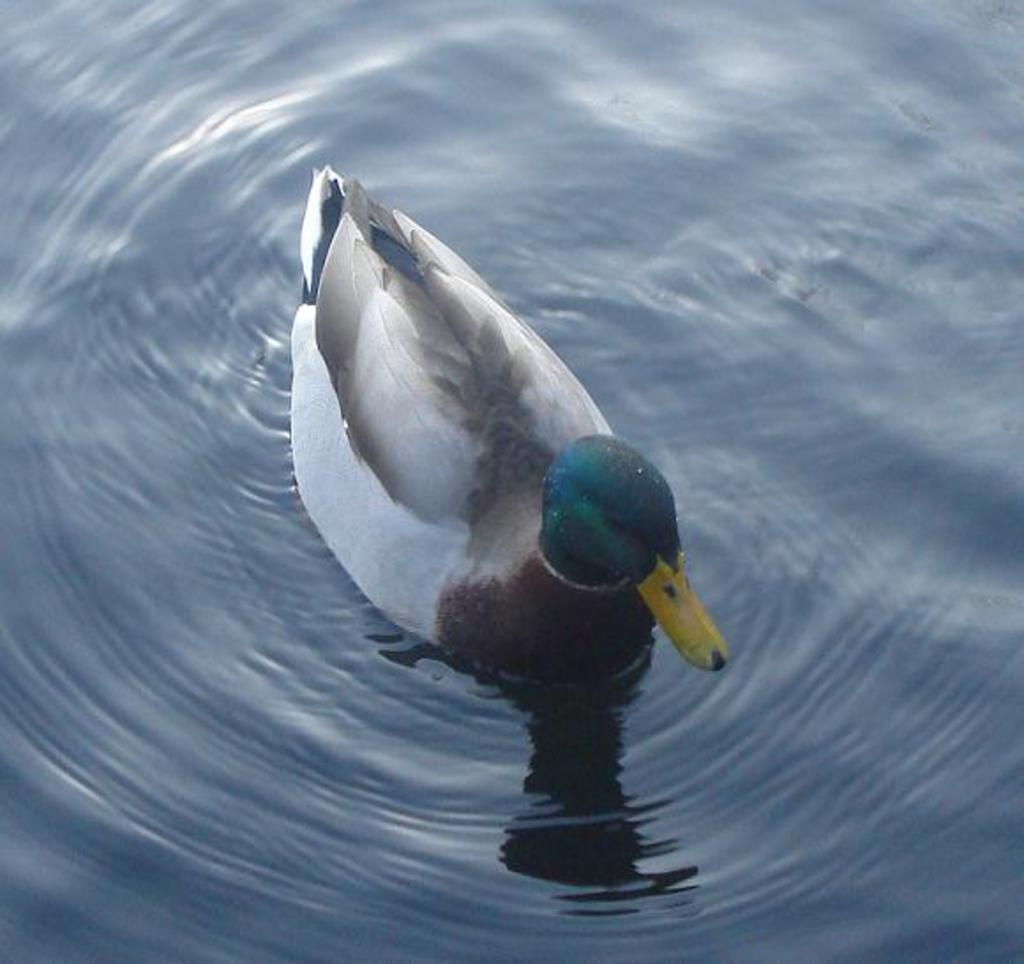What type of animal is in the image? There is a duck in the image. Where is the duck located? The duck is in the water. What colors make up the duck's appearance? The duck is white, black, and blue in color. What type of plant is growing in the duck's beak in the image? There is no plant growing in the duck's beak in the image. How does the duck's wealth affect its ability to swim in the image? The duck's wealth is not mentioned or depicted in the image, and therefore it cannot be determined how it might affect the duck's swimming ability. 